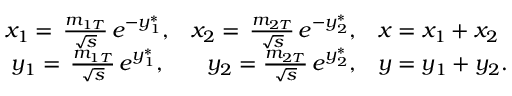Convert formula to latex. <formula><loc_0><loc_0><loc_500><loc_500>\begin{array} { c r l } { { x _ { 1 } = \, \frac { m _ { 1 T } } { \sqrt { s } } \, e ^ { - y _ { 1 } ^ { * } } , } } & { { x _ { 2 } = \, \frac { m _ { 2 T } } { \sqrt { s } } \, e ^ { - y _ { 2 } ^ { * } } , } } & { { x = x _ { 1 } + x _ { 2 } } } \\ { { y _ { 1 } = \, \frac { m _ { 1 T } } { \sqrt { s } } \, e ^ { y _ { 1 } ^ { * } } , } } & { { y _ { 2 } = \frac { m _ { 2 T } } { \sqrt { s } } \, e ^ { y _ { 2 } ^ { * } } , } } & { { y = y _ { 1 } + y _ { 2 } . } } \end{array}</formula> 